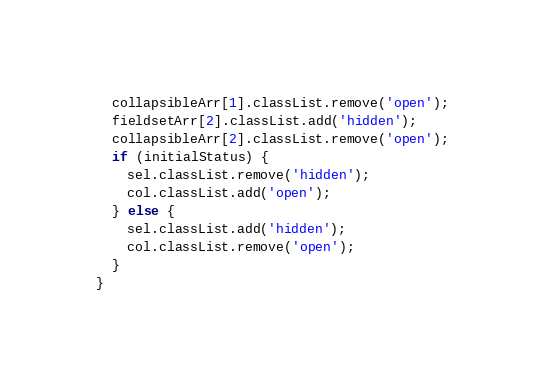Convert code to text. <code><loc_0><loc_0><loc_500><loc_500><_JavaScript_>  collapsibleArr[1].classList.remove('open');
  fieldsetArr[2].classList.add('hidden');
  collapsibleArr[2].classList.remove('open');
  if (initialStatus) {
    sel.classList.remove('hidden');
    col.classList.add('open');
  } else {
    sel.classList.add('hidden');
    col.classList.remove('open');
  }
}
</code> 